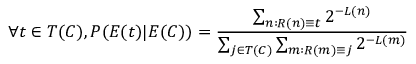<formula> <loc_0><loc_0><loc_500><loc_500>\forall t \in T ( C ) , P ( E ( t ) | E ( C ) ) = { \frac { \sum _ { n \colon R ( n ) \equiv t } 2 ^ { - L ( n ) } } { \sum _ { j \in T ( C ) } \sum _ { m \colon R ( m ) \equiv j } 2 ^ { - L ( m ) } } }</formula> 